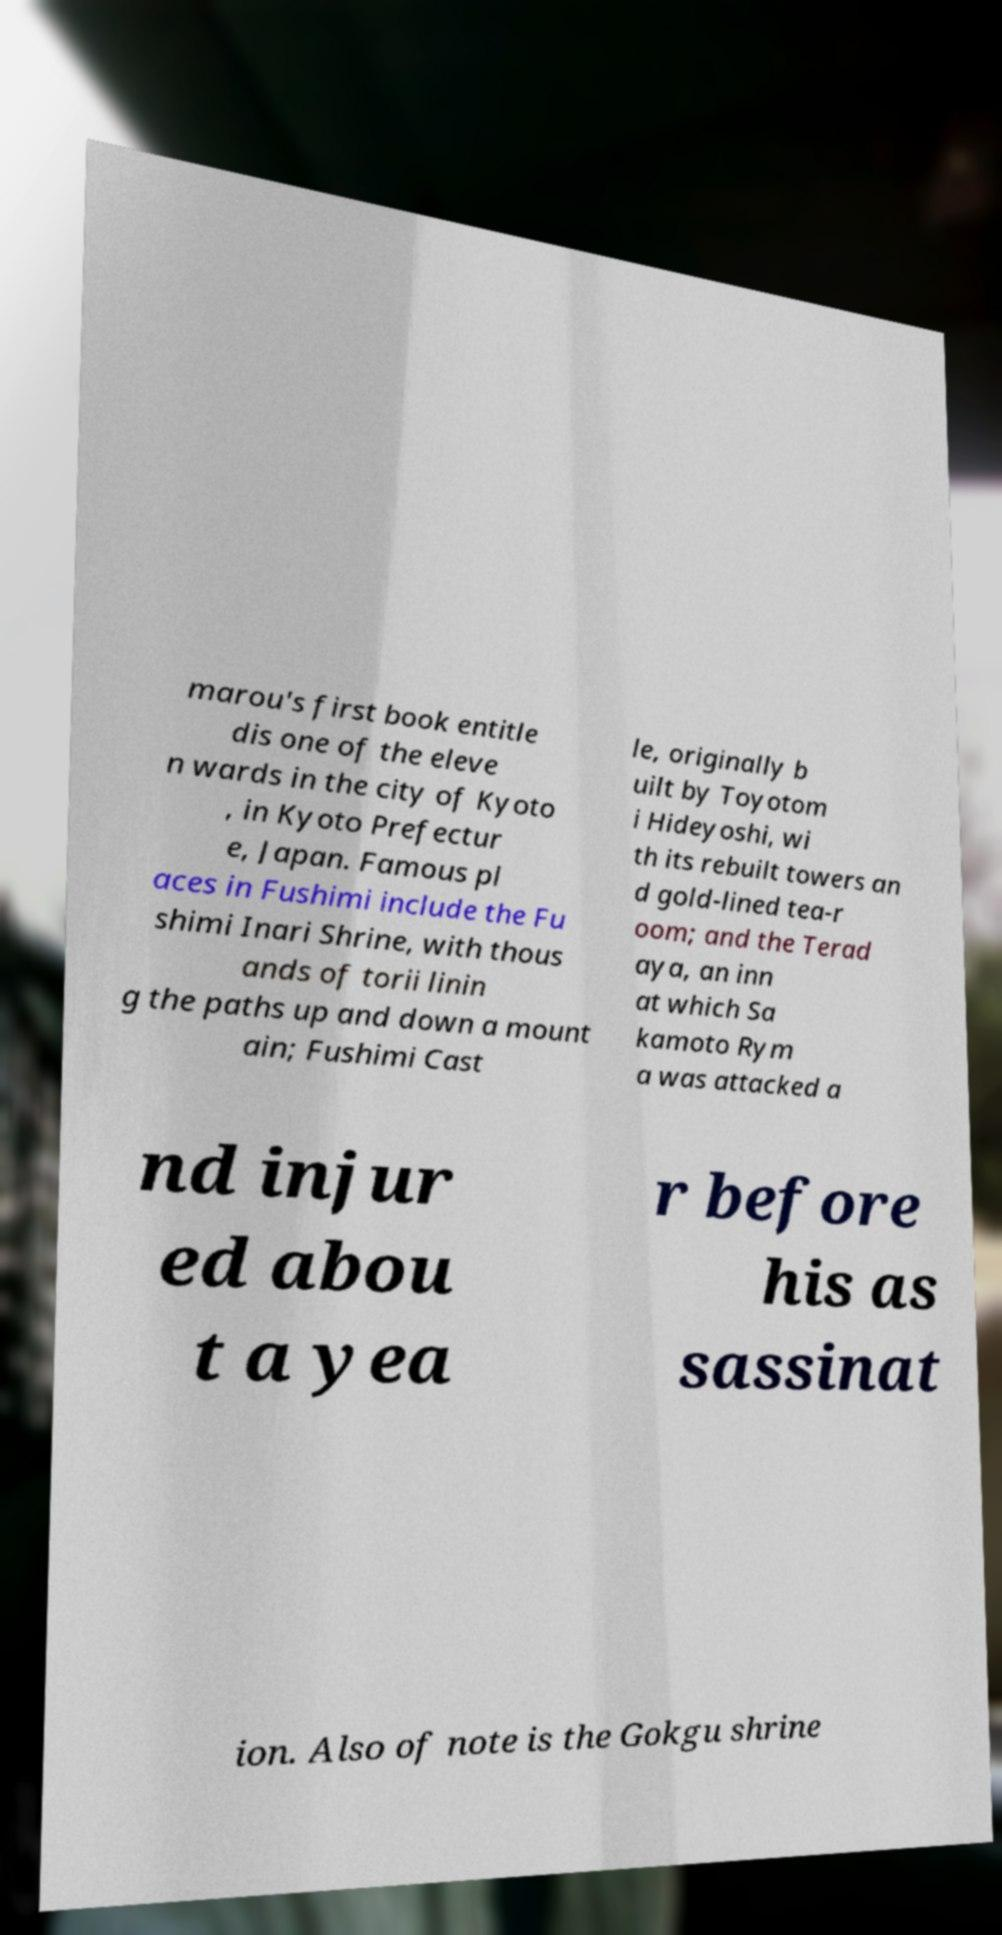Please identify and transcribe the text found in this image. marou's first book entitle dis one of the eleve n wards in the city of Kyoto , in Kyoto Prefectur e, Japan. Famous pl aces in Fushimi include the Fu shimi Inari Shrine, with thous ands of torii linin g the paths up and down a mount ain; Fushimi Cast le, originally b uilt by Toyotom i Hideyoshi, wi th its rebuilt towers an d gold-lined tea-r oom; and the Terad aya, an inn at which Sa kamoto Rym a was attacked a nd injur ed abou t a yea r before his as sassinat ion. Also of note is the Gokgu shrine 